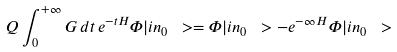<formula> <loc_0><loc_0><loc_500><loc_500>Q \int _ { 0 } ^ { + \infty } G \, d t \, e ^ { - t H } \Phi | i n _ { 0 } \ > = \Phi | i n _ { 0 } \ > - e ^ { - \infty H } \Phi | i n _ { 0 } \ ></formula> 